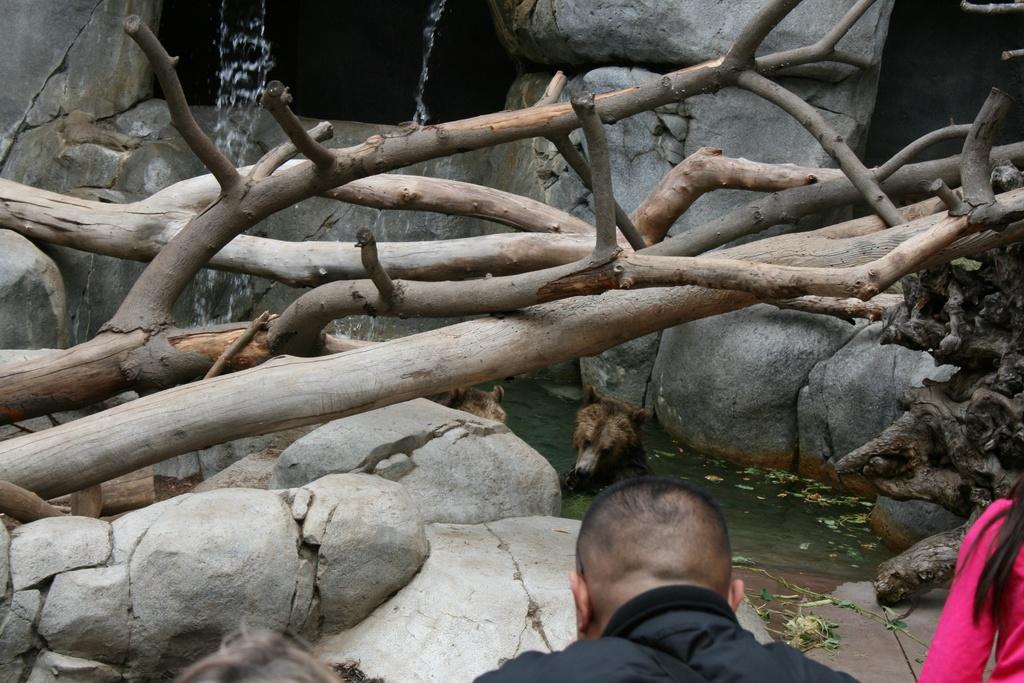What objects made of wood can be seen in the image? There are wooden sticks in the image. What natural element is visible in the image? There is water visible in the image. What type of living creature is present in the image? There is an animal in the image. How many people are in the image? There are two persons in the image. What can be seen in the background of the image? There are rocks in the background of the image. What type of magic is being performed by the animal in the image? There is no magic being performed in the image; it is a natural scene with an animal, water, and wooden sticks. 